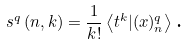Convert formula to latex. <formula><loc_0><loc_0><loc_500><loc_500>s ^ { q } \left ( n , k \right ) = \frac { 1 } { k ! } \left \langle t ^ { k } | ( x ) _ { n } ^ { q } \right \rangle \text {.}</formula> 